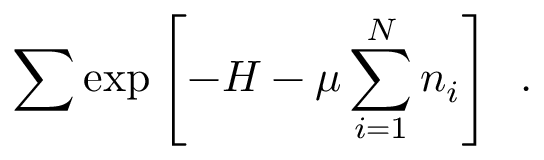Convert formula to latex. <formula><loc_0><loc_0><loc_500><loc_500>\sum \exp { \left [ - H - \mu \sum _ { i = 1 } ^ { N } n _ { i } \right ] } \ \ .</formula> 